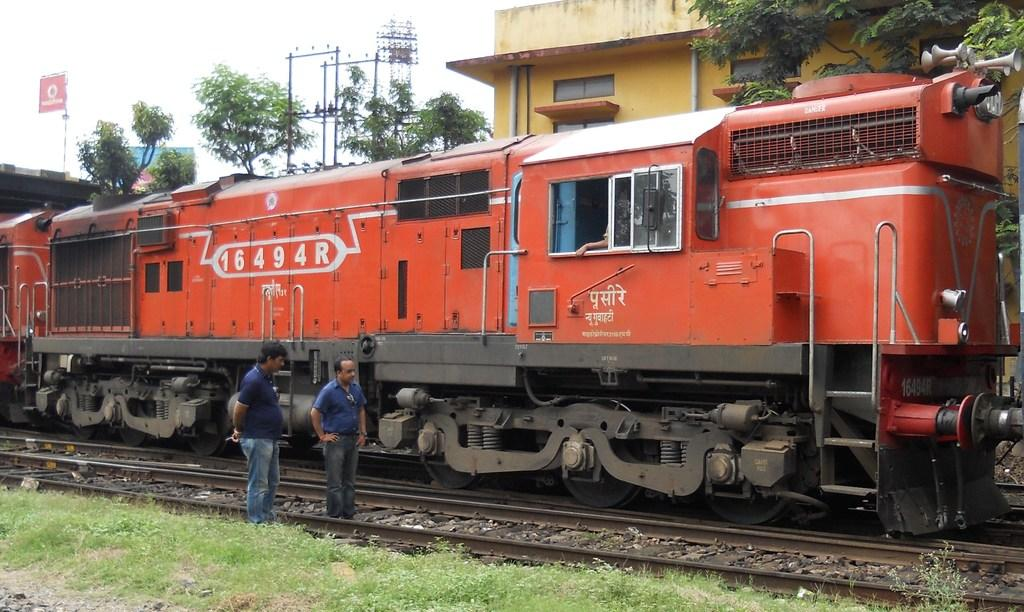<image>
Summarize the visual content of the image. Two men are inspecting an orange train that says 16494R on the side. 